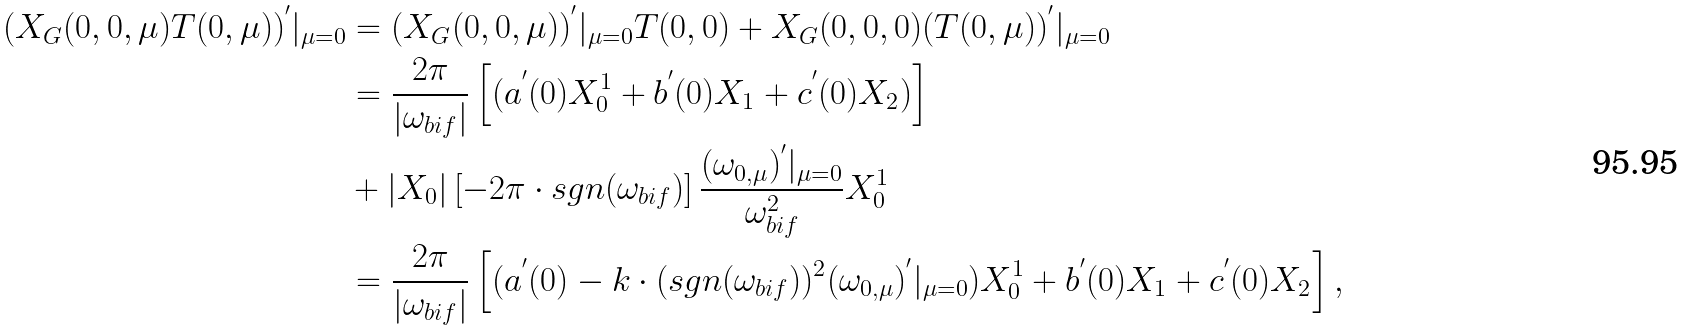<formula> <loc_0><loc_0><loc_500><loc_500>( X _ { G } ( 0 , 0 , \mu ) T ( 0 , \mu ) ) ^ { ^ { \prime } } | _ { \mu = 0 } & = ( X _ { G } ( 0 , 0 , \mu ) ) ^ { ^ { \prime } } | _ { \mu = 0 } T ( 0 , 0 ) + X _ { G } ( 0 , 0 , 0 ) ( T ( 0 , \mu ) ) ^ { ^ { \prime } } | _ { \mu = 0 } \\ & = \frac { 2 \pi } { \left | \omega _ { b i f } \right | } \left [ ( a ^ { ^ { \prime } } ( 0 ) X _ { 0 } ^ { 1 } + b ^ { ^ { \prime } } ( 0 ) X _ { 1 } + c ^ { ^ { \prime } } ( 0 ) X _ { 2 } ) \right ] \\ & + \left | X _ { 0 } \right | \left [ - 2 \pi \cdot s g n ( \omega _ { b i f } ) \right ] \frac { ( \omega _ { 0 , \mu } ) ^ { ^ { \prime } } | _ { \mu = 0 } } { \omega _ { b i f } ^ { 2 } } X _ { 0 } ^ { 1 } \\ & = \frac { 2 \pi } { \left | \omega _ { b i f } \right | } \left [ ( a ^ { ^ { \prime } } ( 0 ) - k \cdot ( s g n ( \omega _ { b i f } ) ) ^ { 2 } ( \omega _ { 0 , \mu } ) ^ { ^ { \prime } } | _ { \mu = 0 } ) X _ { 0 } ^ { 1 } + b ^ { ^ { \prime } } ( 0 ) X _ { 1 } + c ^ { ^ { \prime } } ( 0 ) X _ { 2 } \right ] ,</formula> 